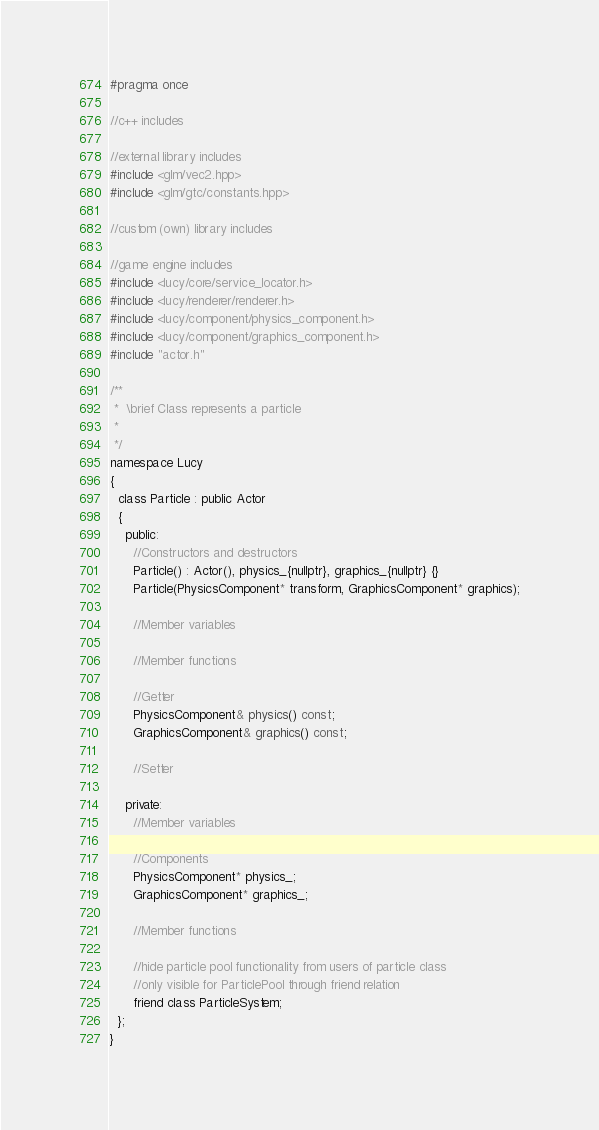Convert code to text. <code><loc_0><loc_0><loc_500><loc_500><_C_>#pragma once

//c++ includes

//external library includes
#include <glm/vec2.hpp>
#include <glm/gtc/constants.hpp>

//custom (own) library includes

//game engine includes
#include <lucy/core/service_locator.h>
#include <lucy/renderer/renderer.h>
#include <lucy/component/physics_component.h>
#include <lucy/component/graphics_component.h>
#include "actor.h"

/**
 *  \brief Class represents a particle
 *
 */
namespace Lucy
{
  class Particle : public Actor
  {
    public:
      //Constructors and destructors
      Particle() : Actor(), physics_{nullptr}, graphics_{nullptr} {}
      Particle(PhysicsComponent* transform, GraphicsComponent* graphics);

      //Member variables

      //Member functions

      //Getter
      PhysicsComponent& physics() const;
      GraphicsComponent& graphics() const;

      //Setter

    private:
      //Member variables
      
      //Components
      PhysicsComponent* physics_;
      GraphicsComponent* graphics_;

      //Member functions 
      
      //hide particle pool functionality from users of particle class
      //only visible for ParticlePool through friend relation
      friend class ParticleSystem;
  };
}</code> 